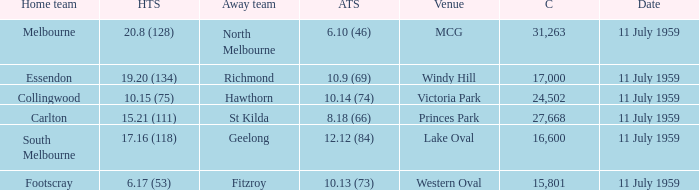What is the home team's score when richmond is away? 19.20 (134). 